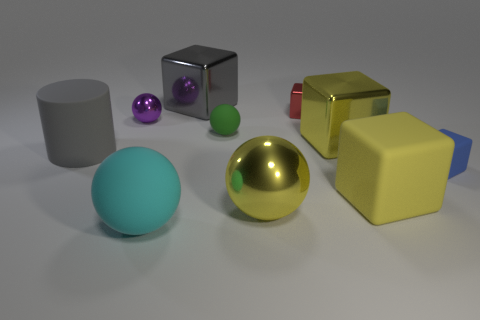Are there fewer big metal balls that are behind the big gray metal block than brown matte things?
Give a very brief answer. No. There is a large cube that is made of the same material as the small blue object; what color is it?
Provide a short and direct response. Yellow. What size is the block that is left of the large metallic sphere?
Your response must be concise. Large. Do the gray cylinder and the small red object have the same material?
Give a very brief answer. No. There is a gray object that is on the right side of the matte sphere that is in front of the yellow shiny sphere; is there a large thing to the left of it?
Make the answer very short. Yes. The tiny shiny ball has what color?
Give a very brief answer. Purple. There is another ball that is the same size as the green ball; what color is it?
Provide a succinct answer. Purple. Does the tiny thing right of the red metal cube have the same shape as the tiny purple metal thing?
Your response must be concise. No. What is the color of the metal object to the left of the big rubber ball in front of the yellow metal thing that is right of the small red thing?
Give a very brief answer. Purple. Are any tiny brown metallic objects visible?
Offer a very short reply. No. 